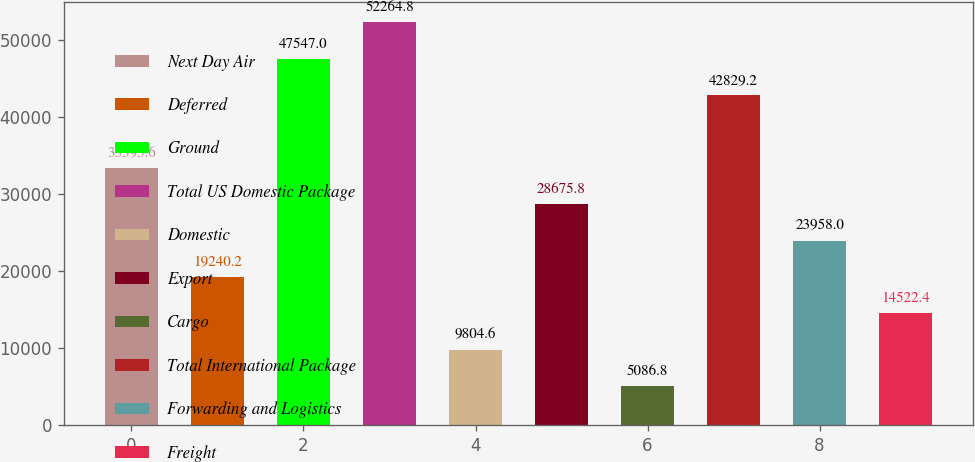Convert chart to OTSL. <chart><loc_0><loc_0><loc_500><loc_500><bar_chart><fcel>Next Day Air<fcel>Deferred<fcel>Ground<fcel>Total US Domestic Package<fcel>Domestic<fcel>Export<fcel>Cargo<fcel>Total International Package<fcel>Forwarding and Logistics<fcel>Freight<nl><fcel>33393.6<fcel>19240.2<fcel>47547<fcel>52264.8<fcel>9804.6<fcel>28675.8<fcel>5086.8<fcel>42829.2<fcel>23958<fcel>14522.4<nl></chart> 